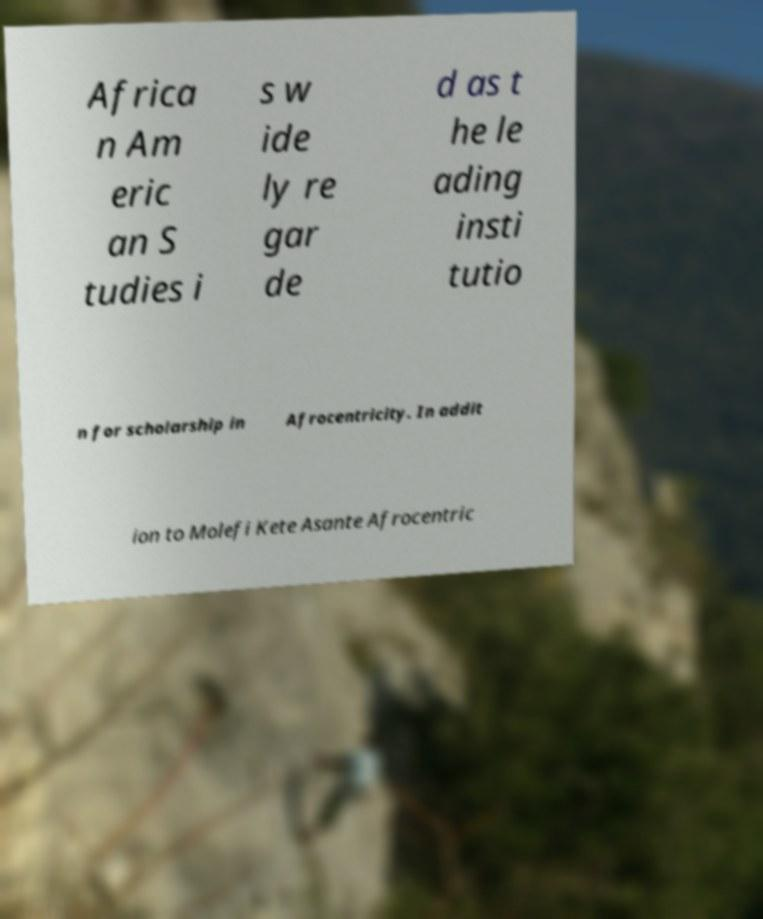There's text embedded in this image that I need extracted. Can you transcribe it verbatim? Africa n Am eric an S tudies i s w ide ly re gar de d as t he le ading insti tutio n for scholarship in Afrocentricity. In addit ion to Molefi Kete Asante Afrocentric 